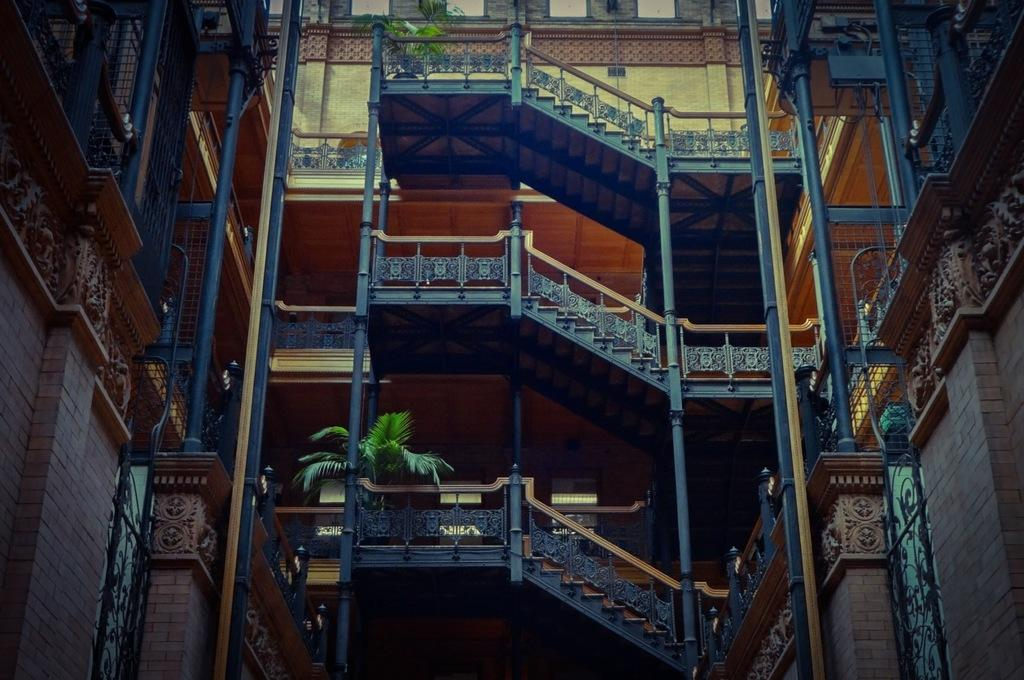What type of structure is present in the image? There is a tall building in the image. What celestial objects can be seen in the image? Stars are visible in the image. What type of vegetation is present in the image? There are plants in the image. Can you see a stamp on the swing in the image? There is no swing or stamp present in the image. 